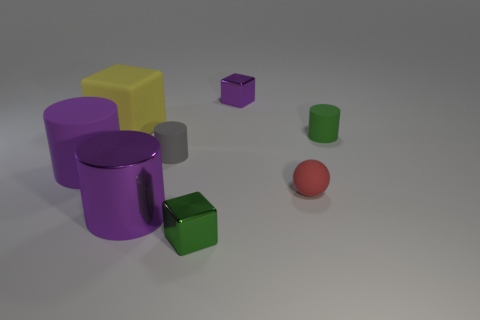Add 1 big cyan metal cylinders. How many objects exist? 9 Subtract all blocks. How many objects are left? 5 Subtract all small brown metallic blocks. Subtract all tiny gray matte cylinders. How many objects are left? 7 Add 7 tiny gray rubber objects. How many tiny gray rubber objects are left? 8 Add 7 small green objects. How many small green objects exist? 9 Subtract 0 yellow spheres. How many objects are left? 8 